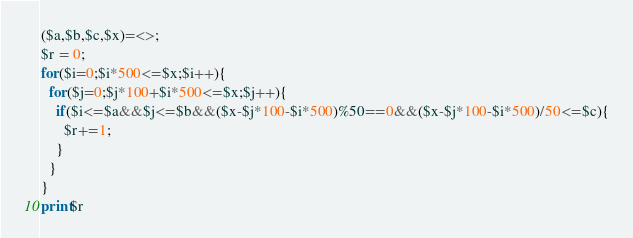<code> <loc_0><loc_0><loc_500><loc_500><_Perl_>($a,$b,$c,$x)=<>;
$r = 0;
for($i=0;$i*500<=$x;$i++){
  for($j=0;$j*100+$i*500<=$x;$j++){
    if($i<=$a&&$j<=$b&&($x-$j*100-$i*500)%50==0&&($x-$j*100-$i*500)/50<=$c){
      $r+=1;
    }
  }
}
print$r</code> 